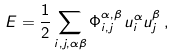Convert formula to latex. <formula><loc_0><loc_0><loc_500><loc_500>E = \frac { 1 } { 2 } \sum _ { i , j , \alpha \beta } \Phi ^ { \alpha , \beta } _ { i , j } \, u ^ { \alpha } _ { i } u ^ { \beta } _ { j } \, ,</formula> 